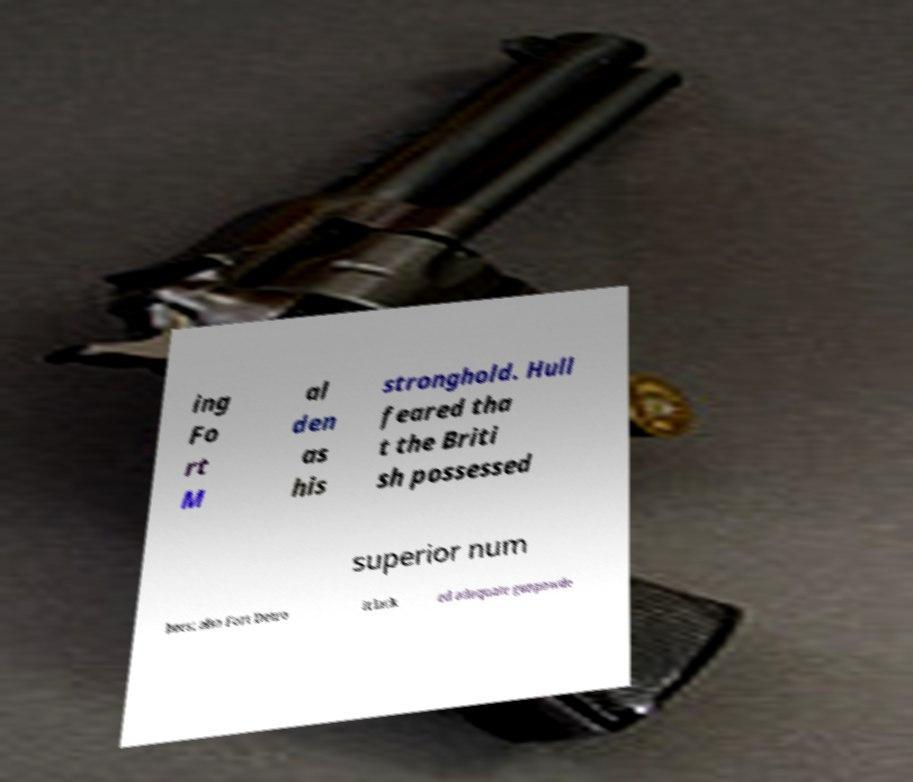For documentation purposes, I need the text within this image transcribed. Could you provide that? ing Fo rt M al den as his stronghold. Hull feared tha t the Briti sh possessed superior num bers; also Fort Detro it lack ed adequate gunpowde 